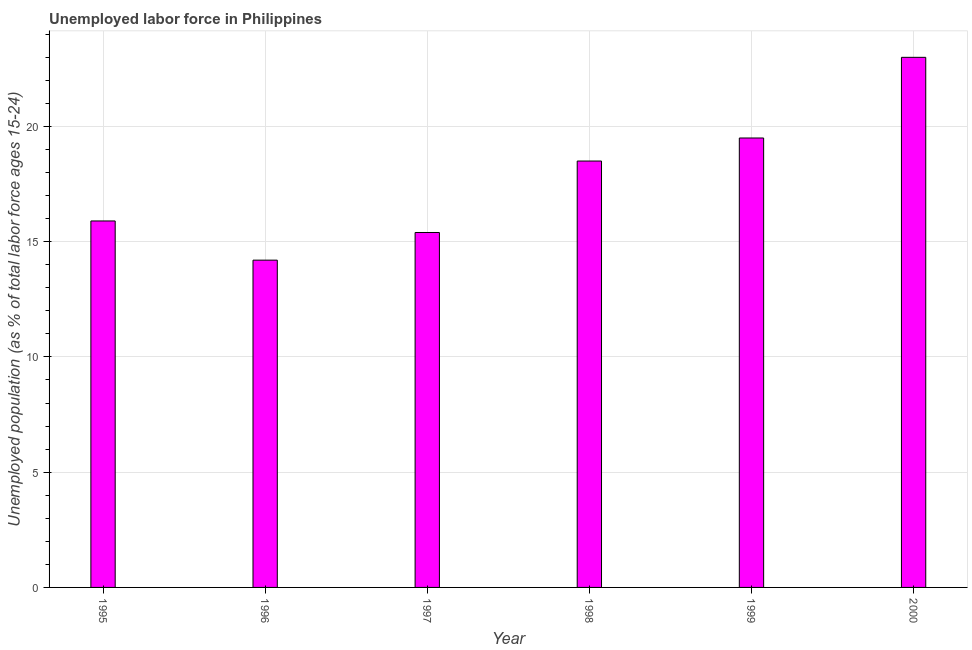What is the title of the graph?
Ensure brevity in your answer.  Unemployed labor force in Philippines. What is the label or title of the X-axis?
Your answer should be very brief. Year. What is the label or title of the Y-axis?
Provide a succinct answer. Unemployed population (as % of total labor force ages 15-24). What is the total unemployed youth population in 1997?
Keep it short and to the point. 15.4. Across all years, what is the maximum total unemployed youth population?
Your answer should be very brief. 23. Across all years, what is the minimum total unemployed youth population?
Offer a terse response. 14.2. In which year was the total unemployed youth population maximum?
Keep it short and to the point. 2000. What is the sum of the total unemployed youth population?
Your response must be concise. 106.5. What is the average total unemployed youth population per year?
Ensure brevity in your answer.  17.75. What is the median total unemployed youth population?
Ensure brevity in your answer.  17.2. In how many years, is the total unemployed youth population greater than 4 %?
Keep it short and to the point. 6. What is the ratio of the total unemployed youth population in 1996 to that in 1999?
Your response must be concise. 0.73. Is the total unemployed youth population in 1996 less than that in 1997?
Provide a succinct answer. Yes. Is the difference between the total unemployed youth population in 1995 and 1999 greater than the difference between any two years?
Keep it short and to the point. No. What is the difference between the highest and the second highest total unemployed youth population?
Your answer should be very brief. 3.5. What is the difference between the highest and the lowest total unemployed youth population?
Your answer should be very brief. 8.8. How many bars are there?
Your response must be concise. 6. How many years are there in the graph?
Offer a terse response. 6. What is the difference between two consecutive major ticks on the Y-axis?
Your response must be concise. 5. Are the values on the major ticks of Y-axis written in scientific E-notation?
Make the answer very short. No. What is the Unemployed population (as % of total labor force ages 15-24) in 1995?
Make the answer very short. 15.9. What is the Unemployed population (as % of total labor force ages 15-24) in 1996?
Make the answer very short. 14.2. What is the Unemployed population (as % of total labor force ages 15-24) in 1997?
Ensure brevity in your answer.  15.4. What is the Unemployed population (as % of total labor force ages 15-24) of 1998?
Provide a succinct answer. 18.5. What is the difference between the Unemployed population (as % of total labor force ages 15-24) in 1995 and 1997?
Offer a terse response. 0.5. What is the difference between the Unemployed population (as % of total labor force ages 15-24) in 1995 and 1998?
Offer a terse response. -2.6. What is the difference between the Unemployed population (as % of total labor force ages 15-24) in 1995 and 2000?
Offer a very short reply. -7.1. What is the difference between the Unemployed population (as % of total labor force ages 15-24) in 1996 and 1997?
Make the answer very short. -1.2. What is the difference between the Unemployed population (as % of total labor force ages 15-24) in 1996 and 1998?
Provide a succinct answer. -4.3. What is the difference between the Unemployed population (as % of total labor force ages 15-24) in 1996 and 1999?
Your answer should be compact. -5.3. What is the difference between the Unemployed population (as % of total labor force ages 15-24) in 1996 and 2000?
Offer a terse response. -8.8. What is the difference between the Unemployed population (as % of total labor force ages 15-24) in 1997 and 1998?
Your answer should be compact. -3.1. What is the difference between the Unemployed population (as % of total labor force ages 15-24) in 1997 and 1999?
Give a very brief answer. -4.1. What is the difference between the Unemployed population (as % of total labor force ages 15-24) in 1998 and 1999?
Make the answer very short. -1. What is the difference between the Unemployed population (as % of total labor force ages 15-24) in 1999 and 2000?
Your answer should be compact. -3.5. What is the ratio of the Unemployed population (as % of total labor force ages 15-24) in 1995 to that in 1996?
Ensure brevity in your answer.  1.12. What is the ratio of the Unemployed population (as % of total labor force ages 15-24) in 1995 to that in 1997?
Provide a succinct answer. 1.03. What is the ratio of the Unemployed population (as % of total labor force ages 15-24) in 1995 to that in 1998?
Your answer should be very brief. 0.86. What is the ratio of the Unemployed population (as % of total labor force ages 15-24) in 1995 to that in 1999?
Give a very brief answer. 0.81. What is the ratio of the Unemployed population (as % of total labor force ages 15-24) in 1995 to that in 2000?
Your response must be concise. 0.69. What is the ratio of the Unemployed population (as % of total labor force ages 15-24) in 1996 to that in 1997?
Provide a short and direct response. 0.92. What is the ratio of the Unemployed population (as % of total labor force ages 15-24) in 1996 to that in 1998?
Provide a succinct answer. 0.77. What is the ratio of the Unemployed population (as % of total labor force ages 15-24) in 1996 to that in 1999?
Provide a short and direct response. 0.73. What is the ratio of the Unemployed population (as % of total labor force ages 15-24) in 1996 to that in 2000?
Provide a succinct answer. 0.62. What is the ratio of the Unemployed population (as % of total labor force ages 15-24) in 1997 to that in 1998?
Make the answer very short. 0.83. What is the ratio of the Unemployed population (as % of total labor force ages 15-24) in 1997 to that in 1999?
Offer a terse response. 0.79. What is the ratio of the Unemployed population (as % of total labor force ages 15-24) in 1997 to that in 2000?
Make the answer very short. 0.67. What is the ratio of the Unemployed population (as % of total labor force ages 15-24) in 1998 to that in 1999?
Offer a terse response. 0.95. What is the ratio of the Unemployed population (as % of total labor force ages 15-24) in 1998 to that in 2000?
Offer a very short reply. 0.8. What is the ratio of the Unemployed population (as % of total labor force ages 15-24) in 1999 to that in 2000?
Make the answer very short. 0.85. 